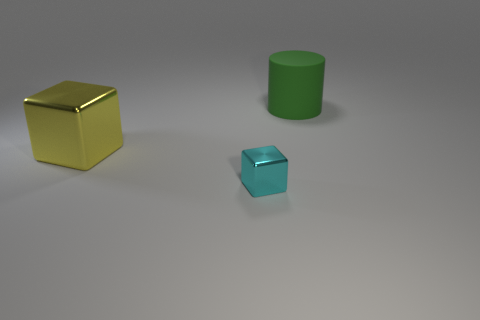What size is the cyan thing that is the same shape as the big yellow metallic thing?
Provide a succinct answer. Small. Is there any other thing that is the same size as the cyan thing?
Your response must be concise. No. What number of other things are there of the same color as the rubber object?
Your answer should be compact. 0. What number of cylinders are either large purple rubber objects or yellow objects?
Offer a very short reply. 0. There is a large thing to the left of the big thing right of the large yellow shiny cube; what color is it?
Provide a succinct answer. Yellow. What is the shape of the green rubber thing?
Provide a short and direct response. Cylinder. Do the shiny object that is left of the cyan cube and the cyan block have the same size?
Provide a short and direct response. No. Is there a small cyan object that has the same material as the yellow thing?
Provide a short and direct response. Yes. What number of things are cubes that are to the right of the large yellow cube or cyan things?
Keep it short and to the point. 1. Are there any tiny cyan rubber cylinders?
Keep it short and to the point. No. 